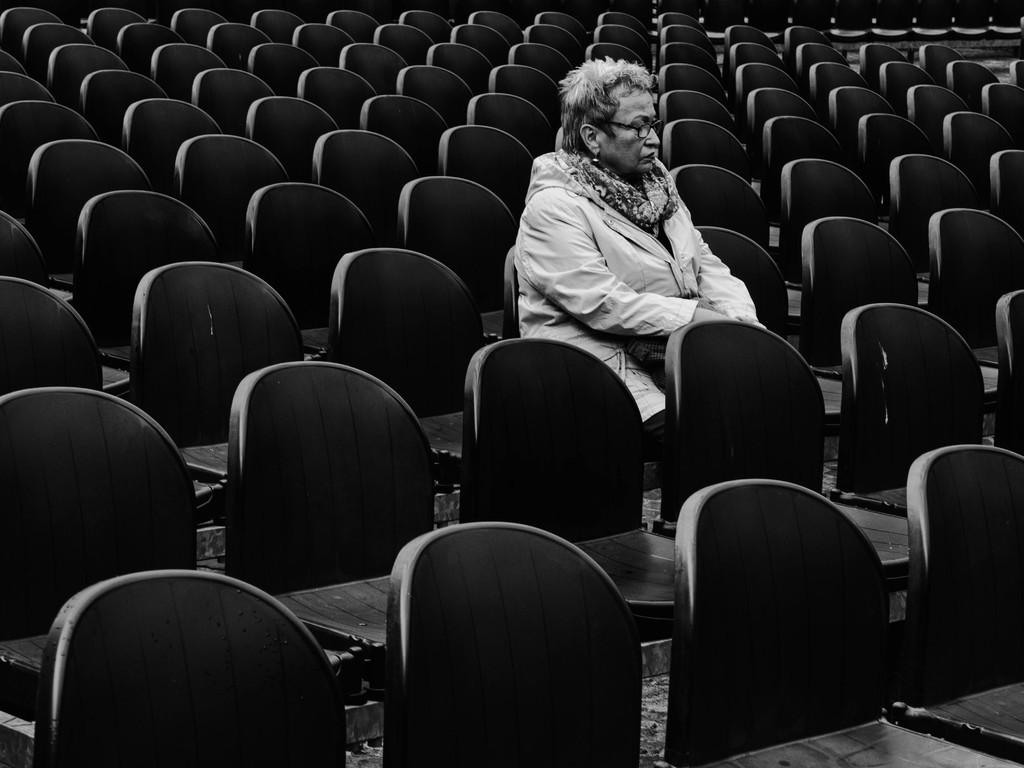What is the main subject of the image? There is a person sitting on a chair in the image. What can be seen in the background of the image? The background of the image includes many chairs. What is the color scheme of the image? The image is in black and white. Can you see any worms crawling on the person's chair in the image? There are no worms present in the image. What type of card is the person holding in the image? There is no card present in the image. 